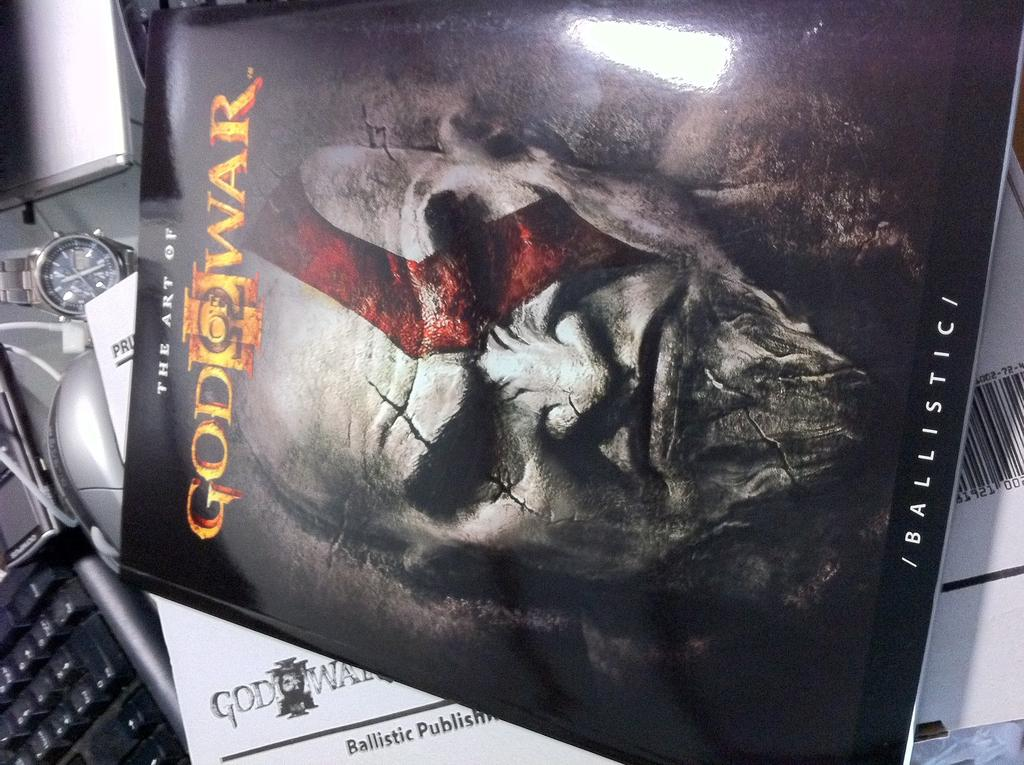What is the main subject of the image? The main subject of the image is a film poster card. What is the title of the film on the poster? The name of the film on the poster is "God war". What else can be seen in the image besides the film poster card? Papers, a keyboard with buttons, and a wrist watch are visible in the image. What is the story behind the rule of balance in the image? There is no mention of a rule or balance in the image, as it primarily features a film poster card and other unrelated items. 